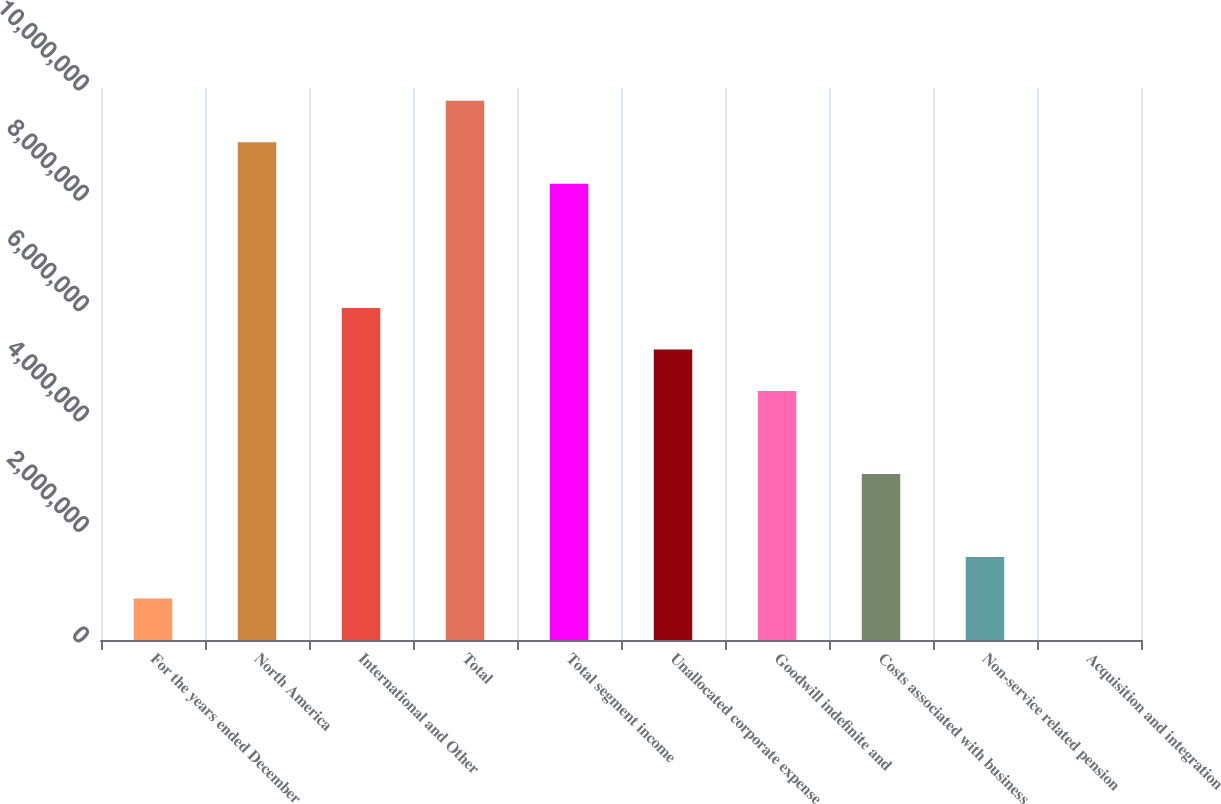Convert chart. <chart><loc_0><loc_0><loc_500><loc_500><bar_chart><fcel>For the years ended December<fcel>North America<fcel>International and Other<fcel>Total<fcel>Total segment income<fcel>Unallocated corporate expense<fcel>Goodwill indefinite and<fcel>Costs associated with business<fcel>Non-service related pension<fcel>Acquisition and integration<nl><fcel>751822<fcel>9.01845e+06<fcel>6.0124e+06<fcel>9.76996e+06<fcel>8.26694e+06<fcel>5.26089e+06<fcel>4.50938e+06<fcel>3.00636e+06<fcel>1.50333e+06<fcel>311<nl></chart> 